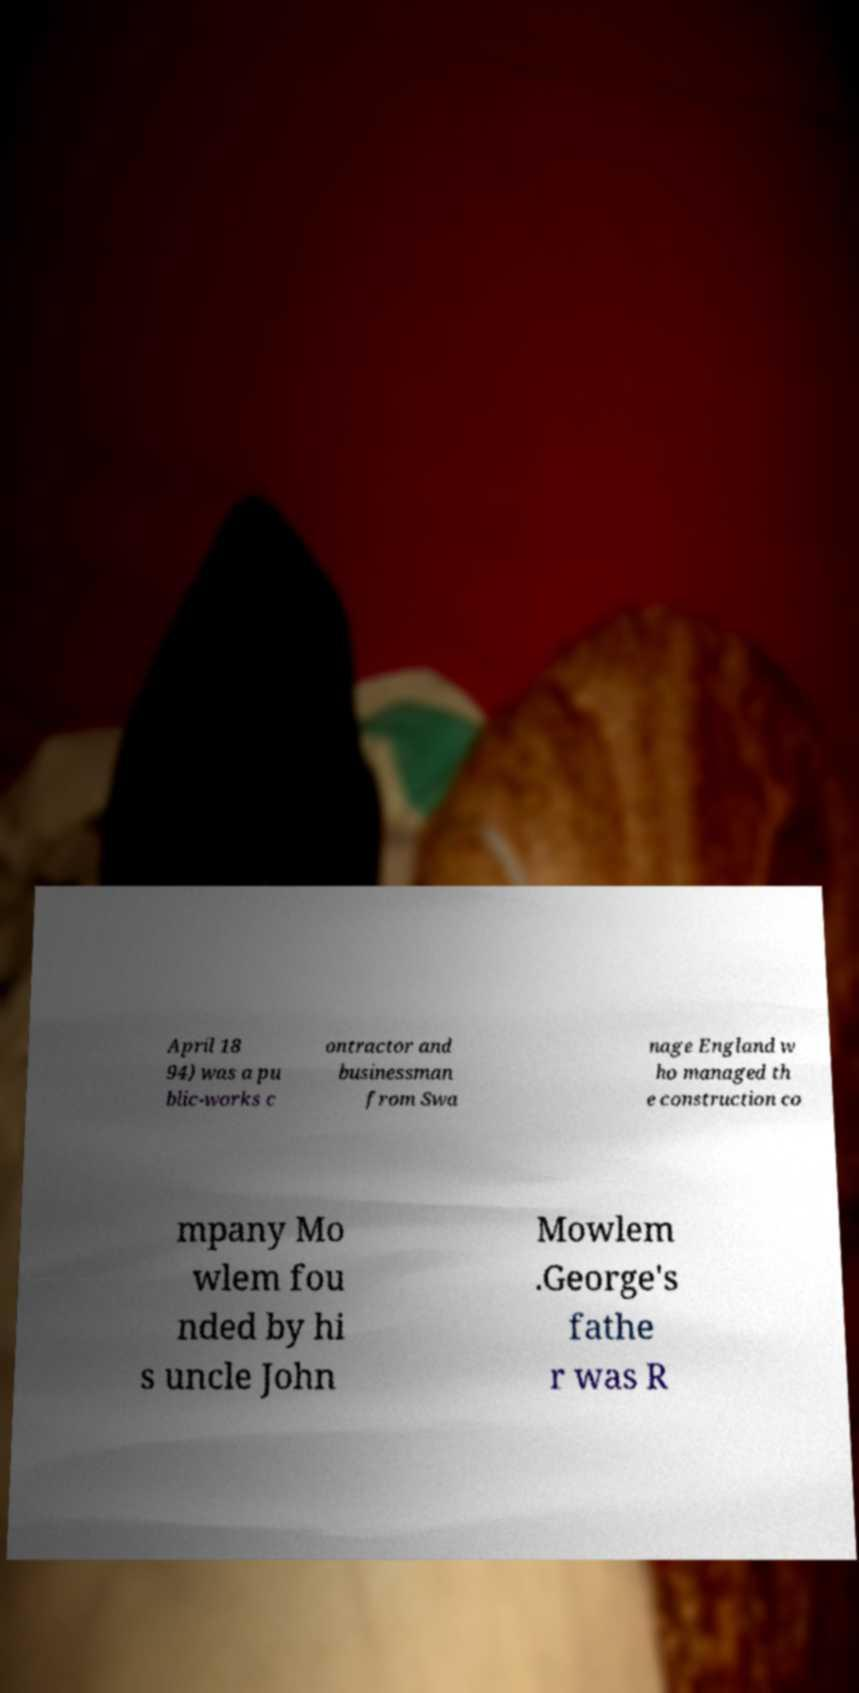Could you extract and type out the text from this image? April 18 94) was a pu blic-works c ontractor and businessman from Swa nage England w ho managed th e construction co mpany Mo wlem fou nded by hi s uncle John Mowlem .George's fathe r was R 